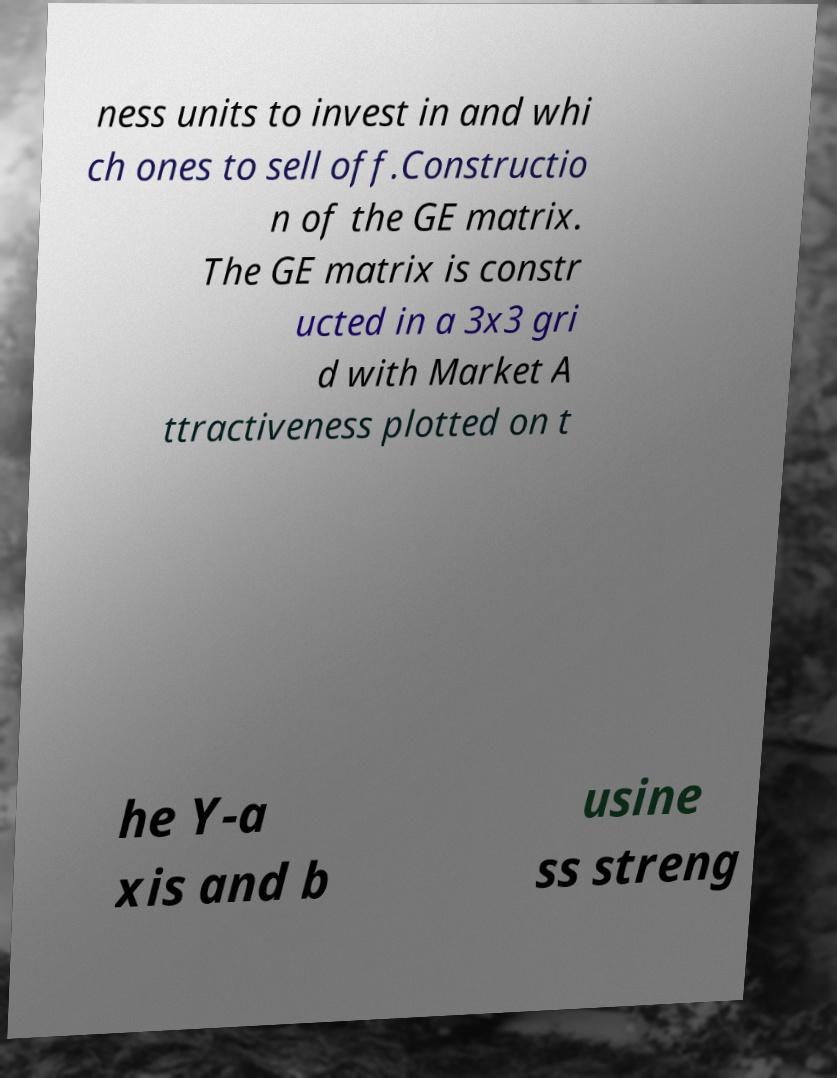For documentation purposes, I need the text within this image transcribed. Could you provide that? ness units to invest in and whi ch ones to sell off.Constructio n of the GE matrix. The GE matrix is constr ucted in a 3x3 gri d with Market A ttractiveness plotted on t he Y-a xis and b usine ss streng 